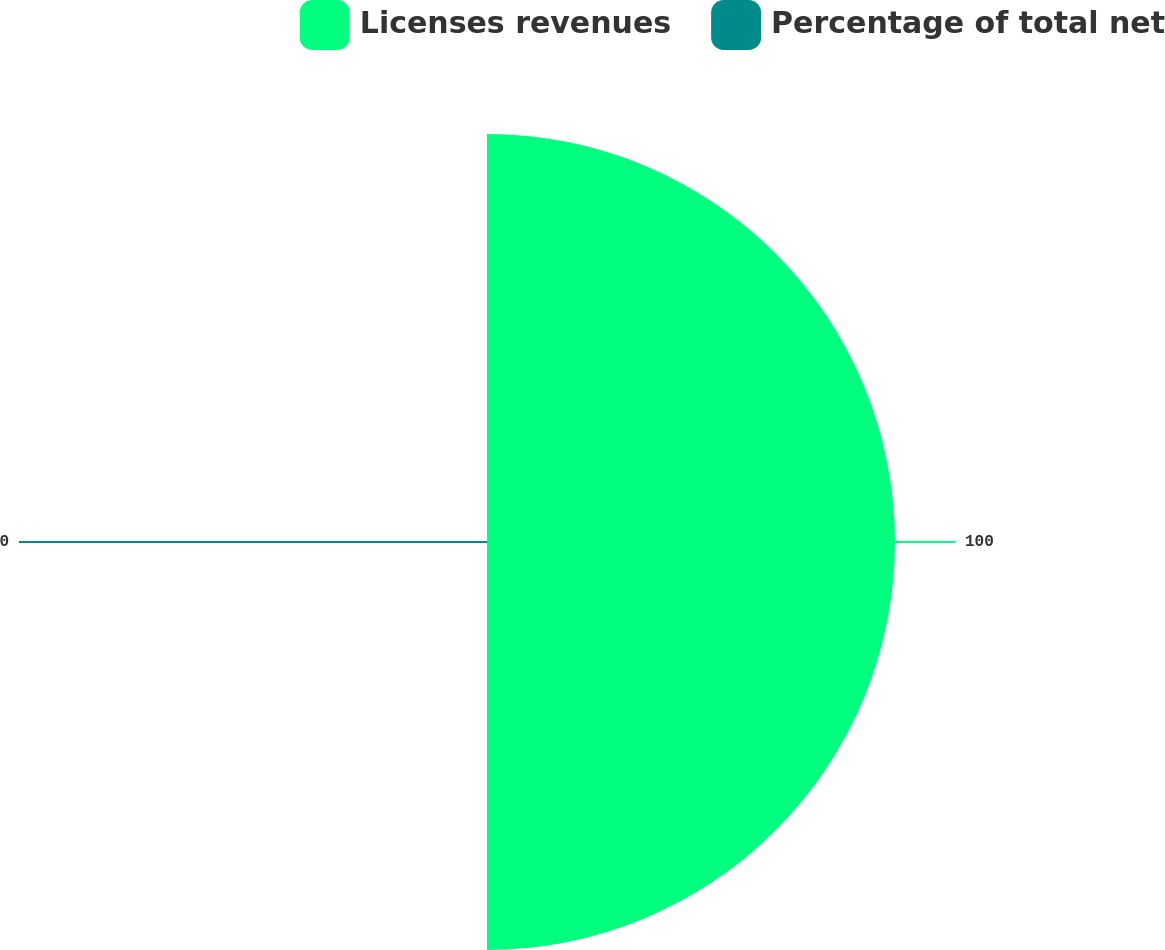Convert chart. <chart><loc_0><loc_0><loc_500><loc_500><pie_chart><fcel>Licenses revenues<fcel>Percentage of total net<nl><fcel>100.0%<fcel>0.0%<nl></chart> 